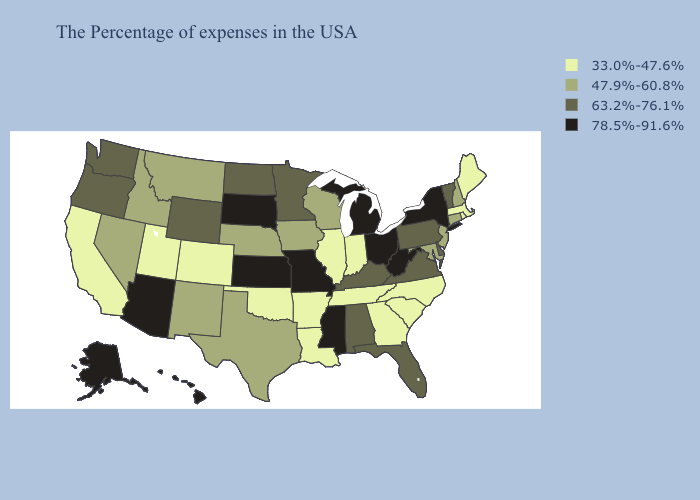Name the states that have a value in the range 63.2%-76.1%?
Write a very short answer. Vermont, Delaware, Pennsylvania, Virginia, Florida, Kentucky, Alabama, Minnesota, North Dakota, Wyoming, Washington, Oregon. Among the states that border Missouri , does Nebraska have the highest value?
Write a very short answer. No. What is the lowest value in the MidWest?
Quick response, please. 33.0%-47.6%. Does Ohio have a higher value than Missouri?
Quick response, please. No. Name the states that have a value in the range 33.0%-47.6%?
Answer briefly. Maine, Massachusetts, Rhode Island, North Carolina, South Carolina, Georgia, Indiana, Tennessee, Illinois, Louisiana, Arkansas, Oklahoma, Colorado, Utah, California. Does the first symbol in the legend represent the smallest category?
Be succinct. Yes. Name the states that have a value in the range 63.2%-76.1%?
Be succinct. Vermont, Delaware, Pennsylvania, Virginia, Florida, Kentucky, Alabama, Minnesota, North Dakota, Wyoming, Washington, Oregon. Name the states that have a value in the range 78.5%-91.6%?
Keep it brief. New York, West Virginia, Ohio, Michigan, Mississippi, Missouri, Kansas, South Dakota, Arizona, Alaska, Hawaii. What is the value of South Dakota?
Answer briefly. 78.5%-91.6%. Does Kansas have the highest value in the MidWest?
Short answer required. Yes. How many symbols are there in the legend?
Give a very brief answer. 4. Name the states that have a value in the range 47.9%-60.8%?
Short answer required. New Hampshire, Connecticut, New Jersey, Maryland, Wisconsin, Iowa, Nebraska, Texas, New Mexico, Montana, Idaho, Nevada. What is the lowest value in states that border New Jersey?
Write a very short answer. 63.2%-76.1%. Name the states that have a value in the range 63.2%-76.1%?
Concise answer only. Vermont, Delaware, Pennsylvania, Virginia, Florida, Kentucky, Alabama, Minnesota, North Dakota, Wyoming, Washington, Oregon. Name the states that have a value in the range 63.2%-76.1%?
Answer briefly. Vermont, Delaware, Pennsylvania, Virginia, Florida, Kentucky, Alabama, Minnesota, North Dakota, Wyoming, Washington, Oregon. 